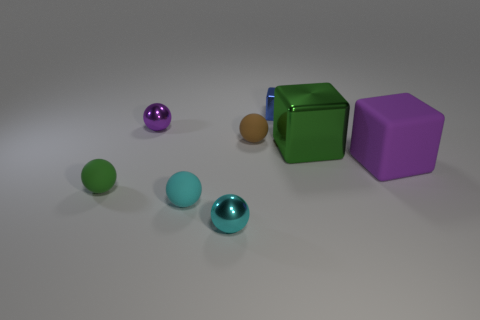The other metallic object that is the same shape as the small blue thing is what color?
Your answer should be compact. Green. What is the shape of the metallic object that is both left of the small brown ball and in front of the brown sphere?
Ensure brevity in your answer.  Sphere. What is the shape of the metallic object that is right of the metallic cube that is behind the small metal ball behind the tiny brown ball?
Offer a terse response. Cube. The blue metal thing is what size?
Make the answer very short. Small. There is a small green thing that is made of the same material as the brown thing; what is its shape?
Provide a succinct answer. Sphere. Are there fewer tiny cyan rubber spheres that are to the left of the small cyan matte thing than brown balls?
Keep it short and to the point. Yes. What is the color of the small thing that is on the left side of the purple metal thing?
Make the answer very short. Green. What material is the tiny object that is the same color as the big shiny object?
Provide a short and direct response. Rubber. Is there a big green metallic thing that has the same shape as the brown thing?
Ensure brevity in your answer.  No. How many cyan matte objects are the same shape as the brown matte thing?
Make the answer very short. 1. 